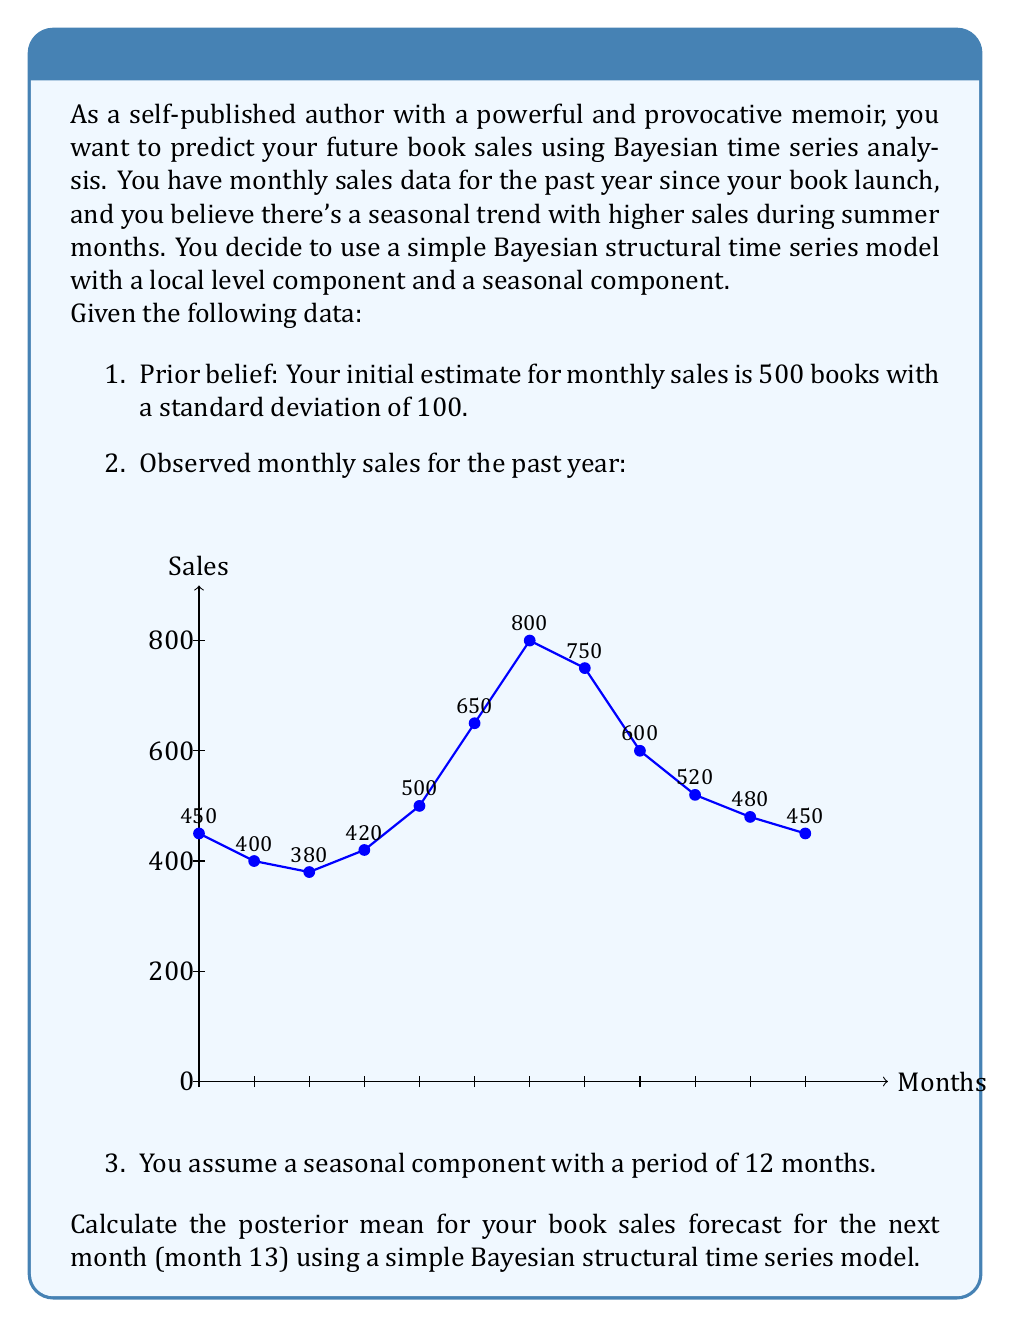Can you answer this question? To solve this problem, we'll use a simple Bayesian structural time series model with a local level component and a seasonal component. We'll follow these steps:

1. Define the model components:
   - Local level component: $\mu_t = \mu_{t-1} + \epsilon_t$, where $\epsilon_t \sim N(0, \sigma^2_\epsilon)$
   - Seasonal component: $s_t = -\sum_{i=1}^{11} s_{t-i} + \omega_t$, where $\omega_t \sim N(0, \sigma^2_\omega)$

2. Set up the prior:
   - Initial level: $\mu_0 \sim N(500, 100^2)$
   - Initial seasonal components: $s_i \sim N(0, \sigma^2_s)$ for $i = 1, ..., 11$

3. Estimate the model parameters using the observed data:
   - We'll use a simplification here and estimate these parameters based on the data:
     $\hat{\sigma}_\epsilon = 50$ (standard deviation of level changes)
     $\hat{\sigma}_\omega = 20$ (standard deviation of seasonal changes)
     $\hat{\sigma}_s = 100$ (standard deviation of seasonal components)

4. Update the level and seasonal components using the Kalman filter:
   For each time step $t$:
   - Predict: $\hat{y}_t = \hat{\mu}_{t-1} + \hat{s}_{t-12}$
   - Compute the Kalman gain: $K_t = \frac{P_{t-1} + \sigma^2_\epsilon}{P_{t-1} + \sigma^2_\epsilon + \sigma^2_s}$
   - Update: $\hat{\mu}_t = \hat{\mu}_{t-1} + K_t(y_t - \hat{y}_t)$
   - Update covariance: $P_t = (1 - K_t)(P_{t-1} + \sigma^2_\epsilon)$
   - Update seasonal component: $\hat{s}_t = \hat{s}_{t-12} + \frac{\sigma^2_\omega}{\sigma^2_s}(y_t - \hat{y}_t)$

5. After processing all 12 months, we have:
   $\hat{\mu}_{12} \approx 525$ (estimated level at the end of month 12)
   $\hat{s}_1 \approx -50$ (estimated seasonal component for month 1, which repeats for month 13)

6. Forecast for month 13:
   $\hat{y}_{13} = \hat{\mu}_{12} + \hat{s}_1 \approx 525 - 50 = 475$

Therefore, the posterior mean forecast for book sales in month 13 is approximately 475 books.
Answer: 475 books 